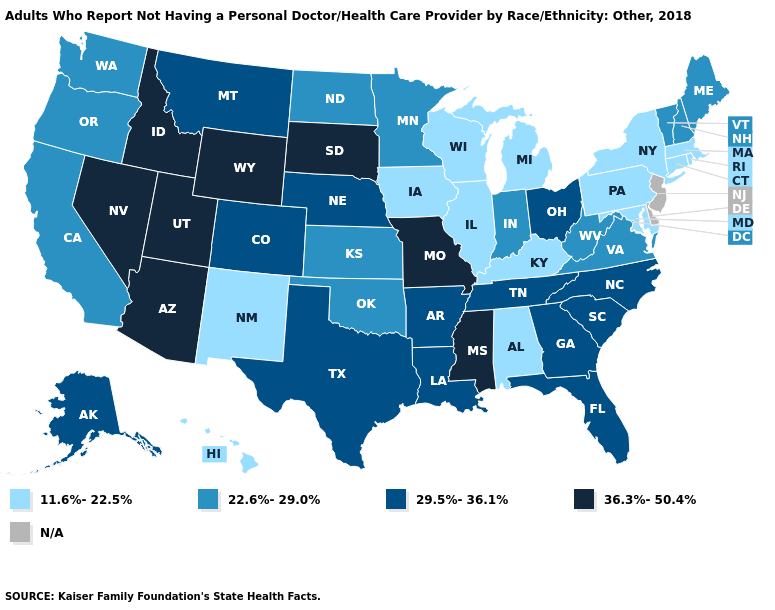What is the highest value in states that border Utah?
Answer briefly. 36.3%-50.4%. Does West Virginia have the lowest value in the USA?
Quick response, please. No. Which states have the lowest value in the South?
Write a very short answer. Alabama, Kentucky, Maryland. What is the value of Washington?
Short answer required. 22.6%-29.0%. Does the first symbol in the legend represent the smallest category?
Answer briefly. Yes. Name the states that have a value in the range 11.6%-22.5%?
Concise answer only. Alabama, Connecticut, Hawaii, Illinois, Iowa, Kentucky, Maryland, Massachusetts, Michigan, New Mexico, New York, Pennsylvania, Rhode Island, Wisconsin. Does Hawaii have the lowest value in the West?
Quick response, please. Yes. How many symbols are there in the legend?
Give a very brief answer. 5. How many symbols are there in the legend?
Be succinct. 5. Does Hawaii have the highest value in the USA?
Give a very brief answer. No. What is the value of Massachusetts?
Answer briefly. 11.6%-22.5%. Name the states that have a value in the range 11.6%-22.5%?
Keep it brief. Alabama, Connecticut, Hawaii, Illinois, Iowa, Kentucky, Maryland, Massachusetts, Michigan, New Mexico, New York, Pennsylvania, Rhode Island, Wisconsin. 